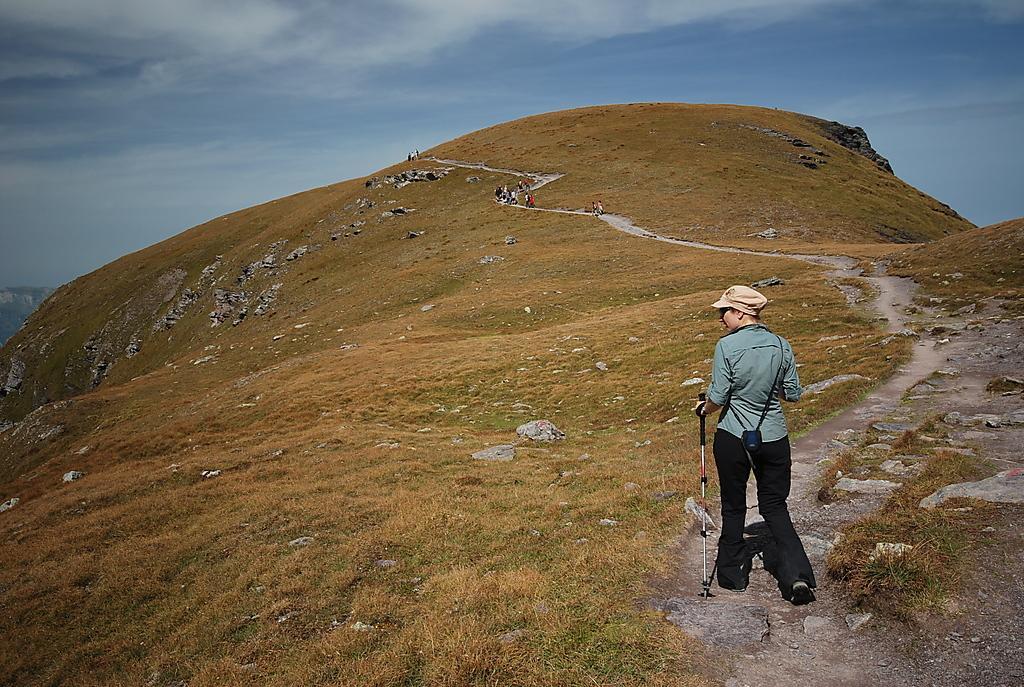Can you describe this image briefly? This image consists of a person walking and holding a stick. At the bottom, there is green grass. It looks like a mountain. In the background, we can see few more persons. At the top, there are clouds in the sky. 